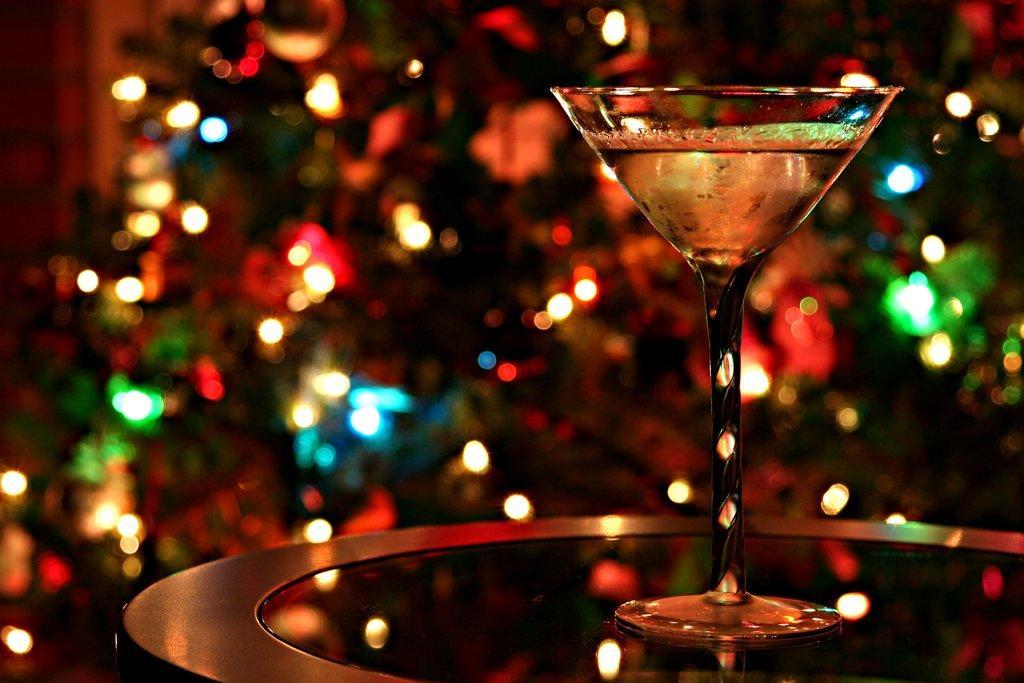In one or two sentences, can you explain what this image depicts? In this image in the front there is a table and on the table there is a glass and the background is blurry.. 